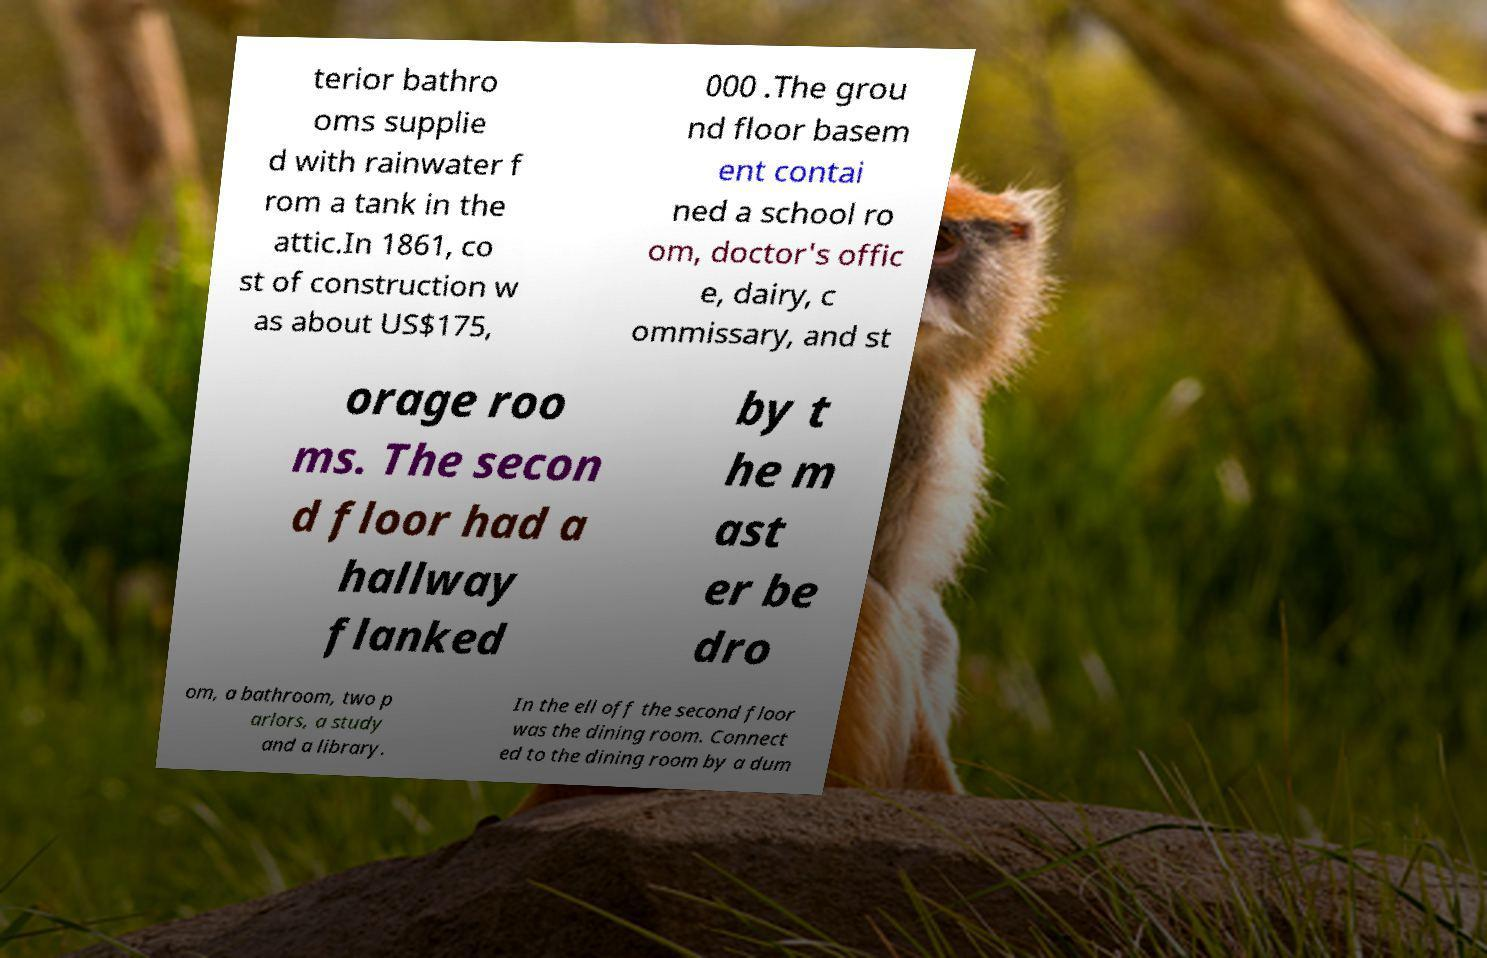There's text embedded in this image that I need extracted. Can you transcribe it verbatim? terior bathro oms supplie d with rainwater f rom a tank in the attic.In 1861, co st of construction w as about US$175, 000 .The grou nd floor basem ent contai ned a school ro om, doctor's offic e, dairy, c ommissary, and st orage roo ms. The secon d floor had a hallway flanked by t he m ast er be dro om, a bathroom, two p arlors, a study and a library. In the ell off the second floor was the dining room. Connect ed to the dining room by a dum 